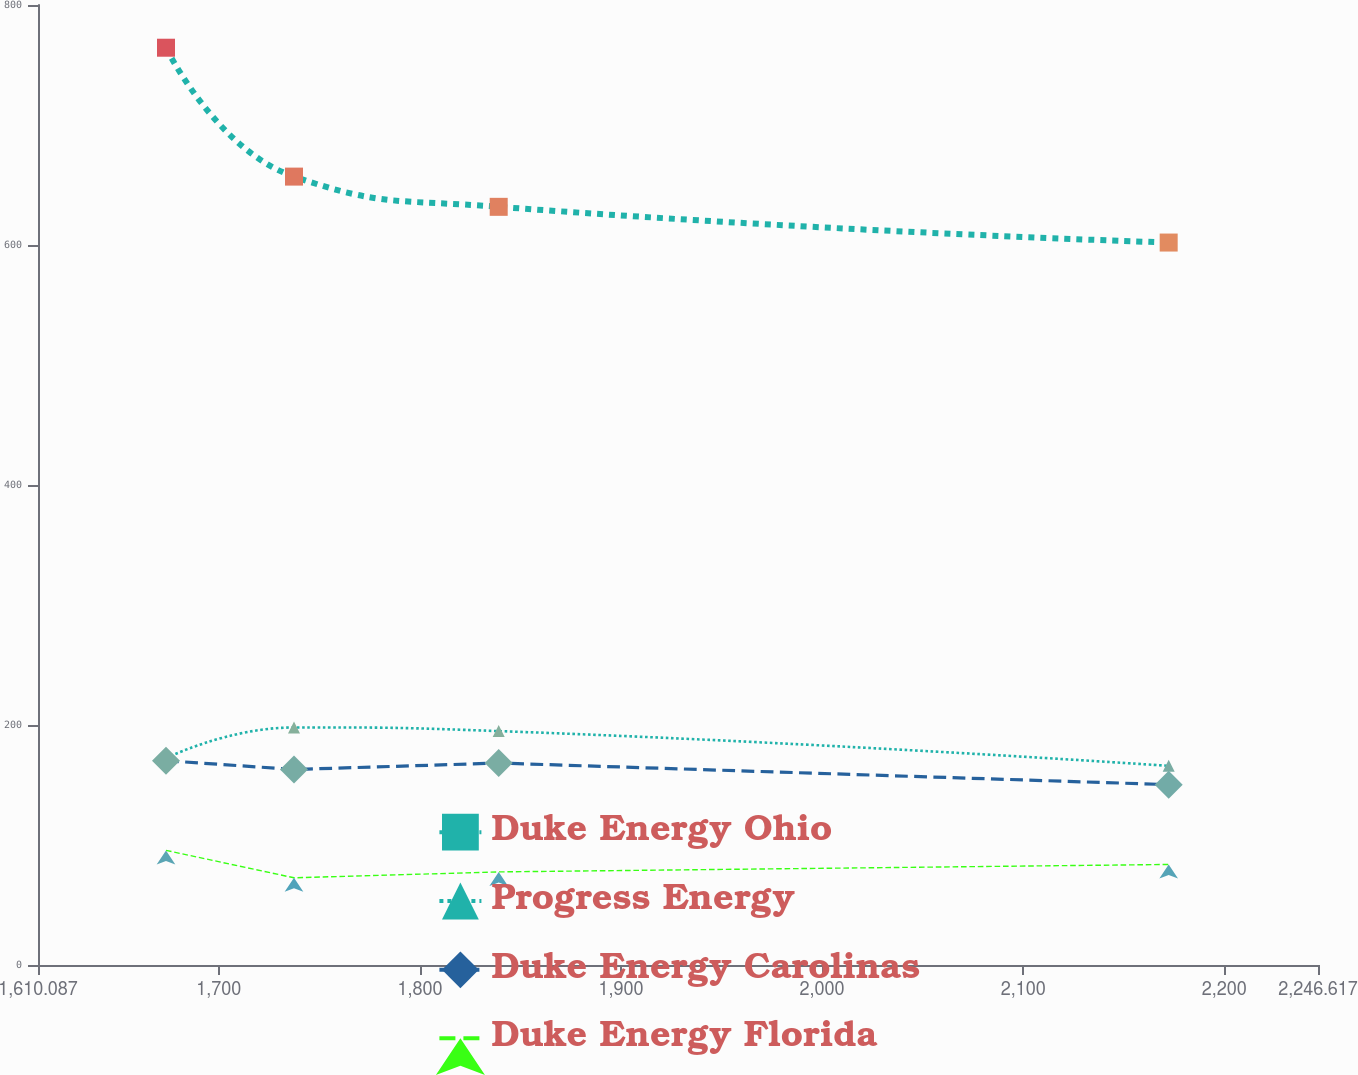Convert chart. <chart><loc_0><loc_0><loc_500><loc_500><line_chart><ecel><fcel>Duke Energy Ohio<fcel>Progress Energy<fcel>Duke Energy Carolinas<fcel>Duke Energy Florida<nl><fcel>1673.74<fcel>764.4<fcel>172.39<fcel>170.24<fcel>95.52<nl><fcel>1737.39<fcel>657<fcel>197.97<fcel>162.94<fcel>72.66<nl><fcel>1839.19<fcel>631.81<fcel>194.92<fcel>168.28<fcel>77.57<nl><fcel>2172.36<fcel>602.05<fcel>165.96<fcel>150.31<fcel>83.79<nl><fcel>2310.27<fcel>780.97<fcel>190.79<fcel>164.9<fcel>86.85<nl></chart> 